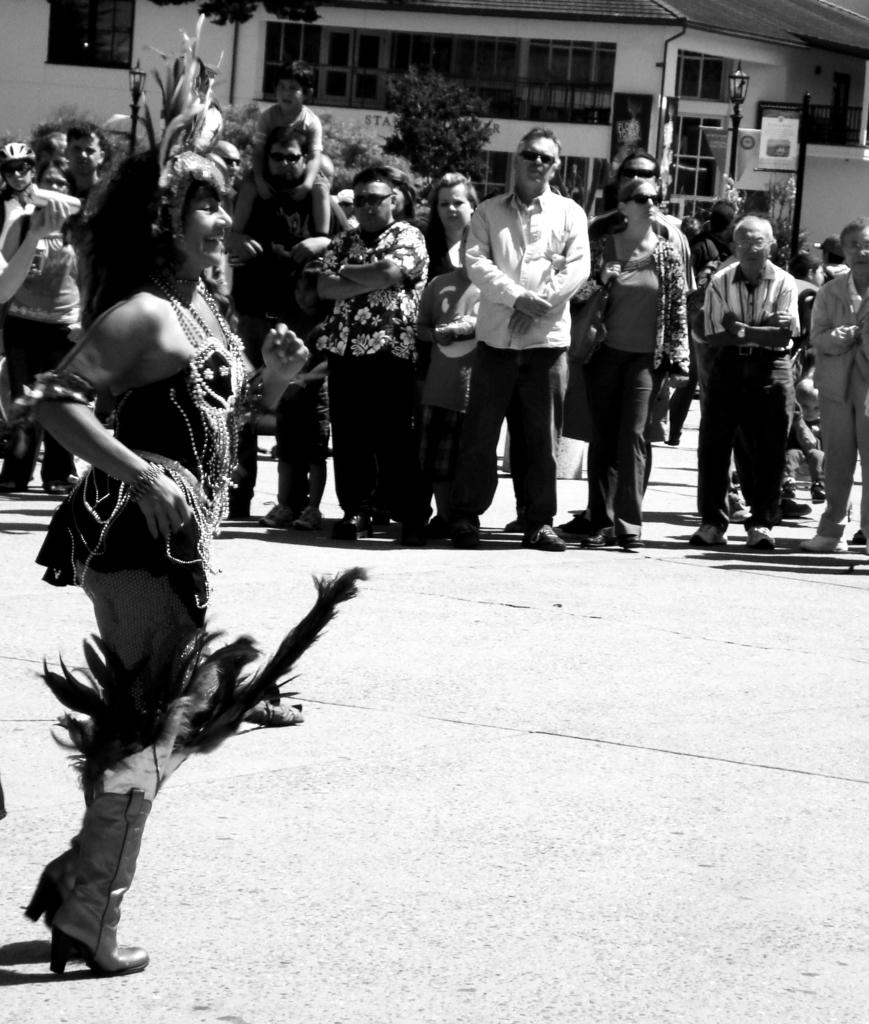How many people are in the image? There are people in the image, but the exact number is not specified. What is unique about one person's appearance? One person is wearing a costume. What can be seen in the background of the image? There is a shed and trees visible in the background of the image. What objects are present in the image? There are poles in the image. What type of bubble is being blown by the person in the costume? There is no bubble present in the image. What cut of beef is being served at the event in the image? There is no mention of any food, including beef, in the image. 